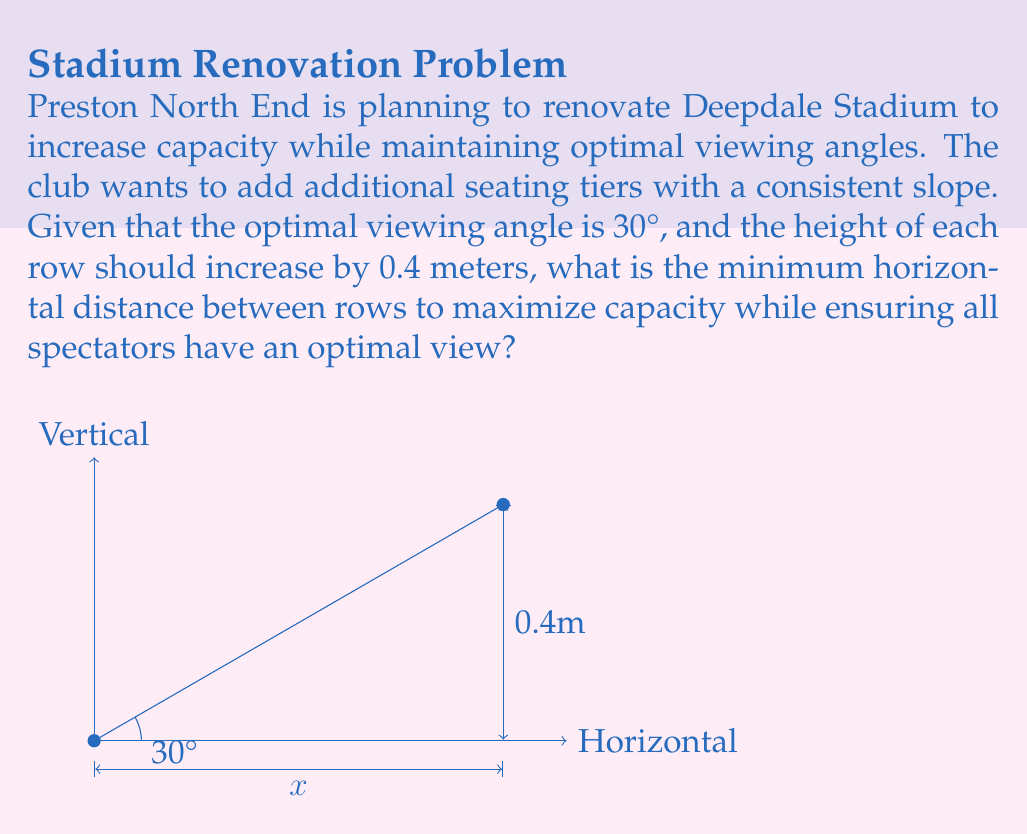Can you solve this math problem? To solve this problem, we'll use trigonometry:

1) We know the optimal viewing angle is 30° and the vertical rise between rows is 0.4 meters.

2) Let's call the horizontal distance between rows $x$.

3) We can create a right-angled triangle where:
   - The opposite side is 0.4 meters (vertical rise)
   - The hypotenuse forms the 30° angle with the horizontal
   - The adjacent side is the horizontal distance $x$ we're trying to find

4) Using the tangent function:

   $$\tan(30°) = \frac{\text{opposite}}{\text{adjacent}} = \frac{0.4}{x}$$

5) We know that $\tan(30°) = \frac{1}{\sqrt{3}}$, so we can set up the equation:

   $$\frac{1}{\sqrt{3}} = \frac{0.4}{x}$$

6) Cross-multiply:

   $$x = 0.4 \sqrt{3}$$

7) Simplify:

   $$x \approx 0.693 \text{ meters}$$

This is the minimum horizontal distance between rows that will maintain the optimal 30° viewing angle while maximizing capacity.
Answer: 0.693 meters 